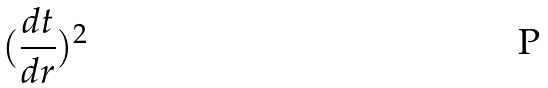Convert formula to latex. <formula><loc_0><loc_0><loc_500><loc_500>( \frac { d t } { d r } ) ^ { 2 }</formula> 